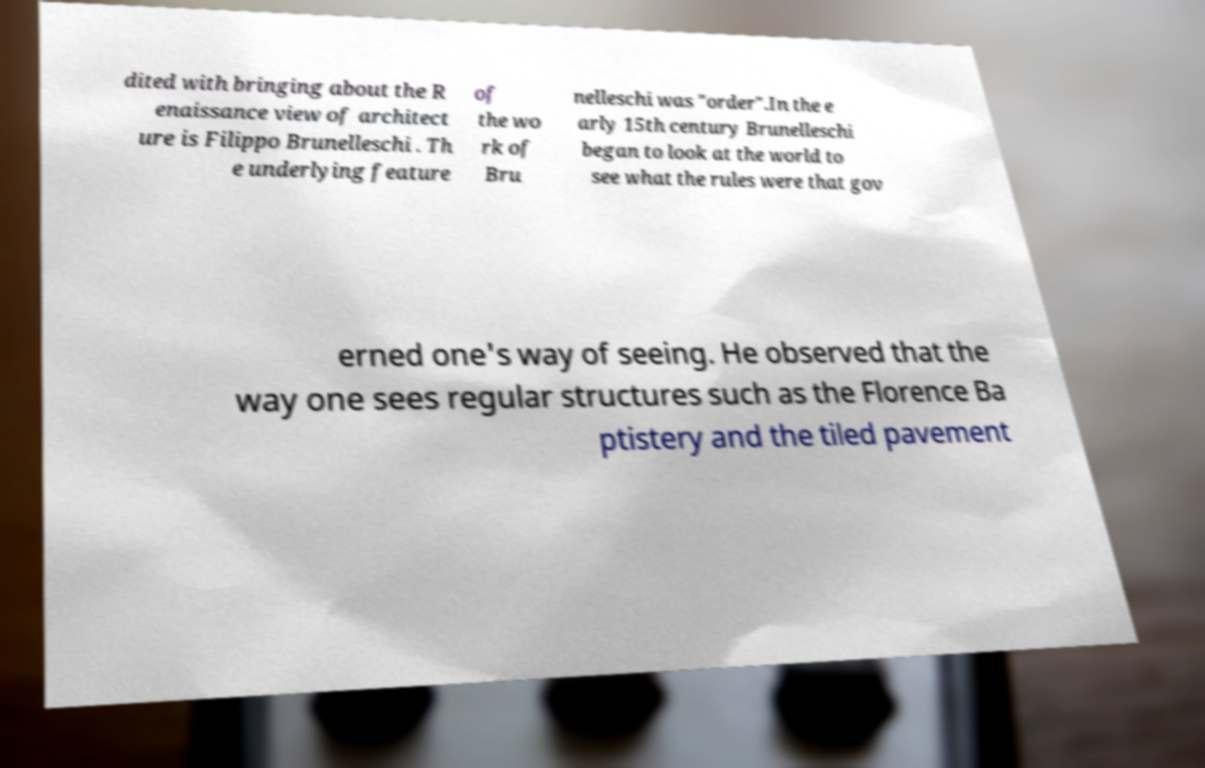Can you accurately transcribe the text from the provided image for me? dited with bringing about the R enaissance view of architect ure is Filippo Brunelleschi . Th e underlying feature of the wo rk of Bru nelleschi was "order".In the e arly 15th century Brunelleschi began to look at the world to see what the rules were that gov erned one's way of seeing. He observed that the way one sees regular structures such as the Florence Ba ptistery and the tiled pavement 